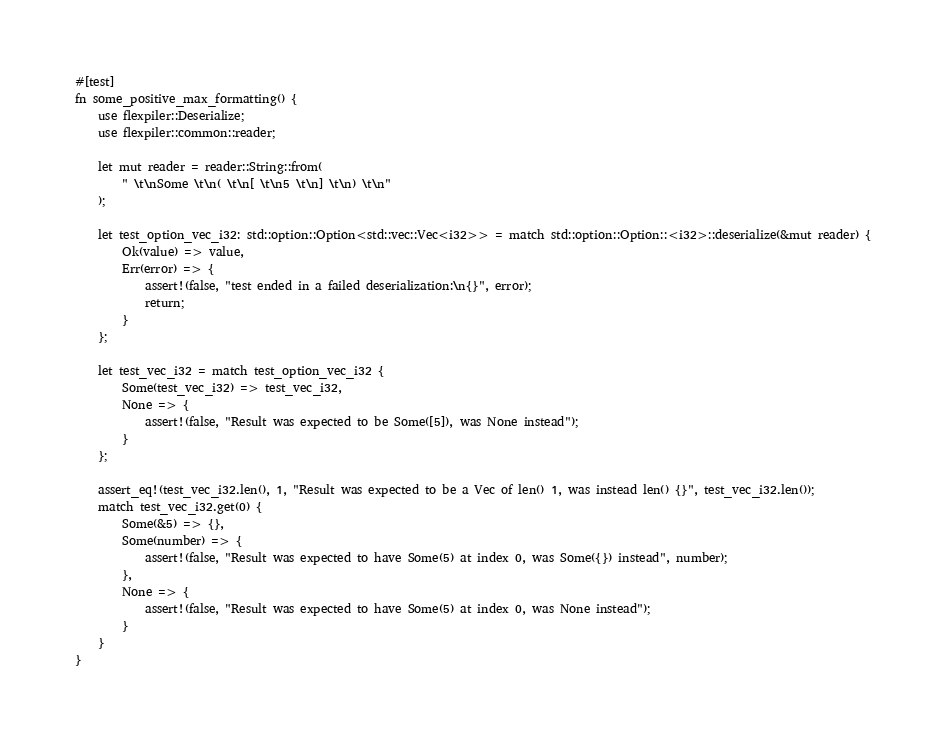<code> <loc_0><loc_0><loc_500><loc_500><_Rust_>

#[test]
fn some_positive_max_formatting() {
    use flexpiler::Deserialize;
    use flexpiler::common::reader;

    let mut reader = reader::String::from(
        " \t\nSome \t\n( \t\n[ \t\n5 \t\n] \t\n) \t\n"
    );

    let test_option_vec_i32: std::option::Option<std::vec::Vec<i32>> = match std::option::Option::<i32>::deserialize(&mut reader) {
        Ok(value) => value,
        Err(error) => {
            assert!(false, "test ended in a failed deserialization:\n{}", error);
            return;
        }
    };

    let test_vec_i32 = match test_option_vec_i32 {
        Some(test_vec_i32) => test_vec_i32,
        None => {
            assert!(false, "Result was expected to be Some([5]), was None instead");
        }
    };

    assert_eq!(test_vec_i32.len(), 1, "Result was expected to be a Vec of len() 1, was instead len() {}", test_vec_i32.len());
    match test_vec_i32.get(0) {
        Some(&5) => {},
        Some(number) => {
            assert!(false, "Result was expected to have Some(5) at index 0, was Some({}) instead", number);
        },
        None => {
            assert!(false, "Result was expected to have Some(5) at index 0, was None instead");
        }
    }
}

</code> 